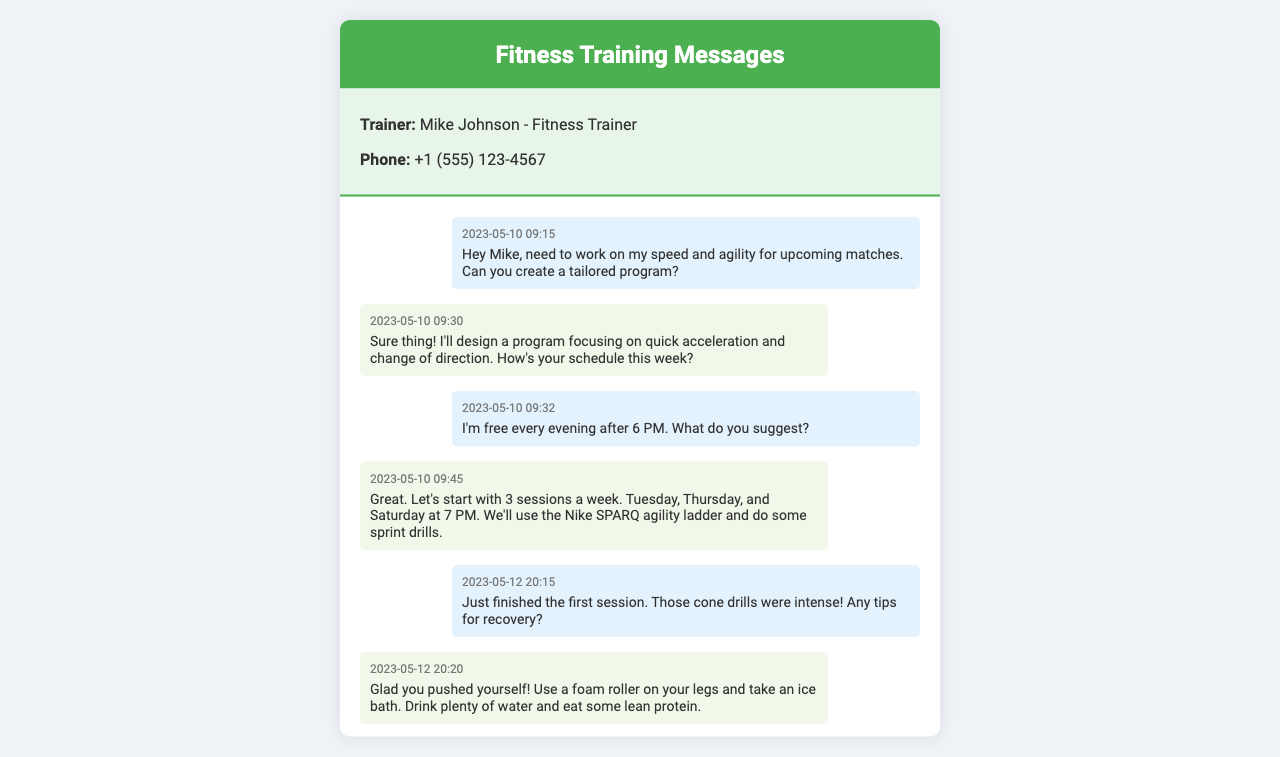What is the trainer's name? The trainer's name is provided in the contact info section of the document.
Answer: Mike Johnson What time did the first message get sent? The first message is displayed with a timestamp, which indicates when it was sent.
Answer: 09:15 How many sessions were suggested per week? The document outlines the training schedule, specifying the number of sessions per week.
Answer: 3 What tool will be used for lateral movement exercises? The trainer mentions a specific item that will be utilized in the training for lateral movements.
Answer: Resistance band Which day is the explosive starts session planned for? The document states a specific day when the explosive starts session will take place.
Answer: Tomorrow How did the athlete feel after the first training session? There is a feedback message from the athlete regarding their feelings after the training session.
Answer: Much quicker What is the date of the last message exchanged? The most recent message indicates when it was sent, which helps identify the date of the last communication.
Answer: 2023-05-25 What type of drills will be included in the next session? The document specifies the type of drills that will be incorporated into the upcoming training session.
Answer: Dribbling drills 